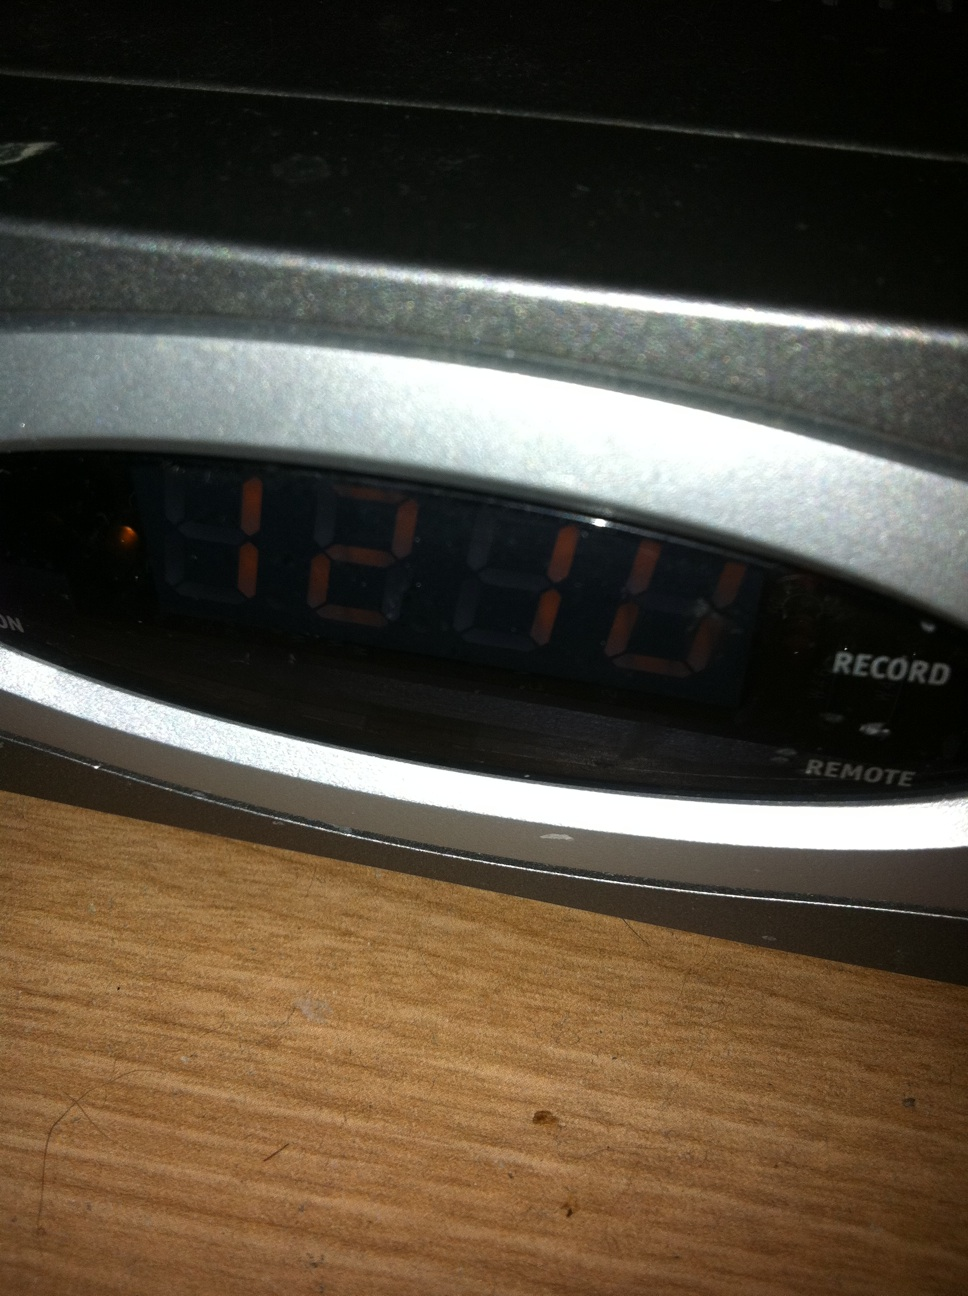Can you describe the overall look and condition of the set-top box? The set-top box appears to be in good condition with a sleek, metallic finish. There are no visible scratches or damage on the surface, which indicates it has been well-maintained. The display is clear, showing '12:10' with its illuminated digits. Additionally, there are labels such as 'RECORD' and 'REMOTE' visible on the interface, suggesting functionality for recording and remote control operations. Does the set-top box seem to have any advanced features? Based on the visible features, the set-top box does include functionalities such as recording, which could suggest it is a DVR (Digital Video Recorder). The presence of a 'REMOTE' label also implies it is remote-controllable. However, without seeing more of the device or having additional information, I cannot verify further advanced features like internet connectivity or smart functionalities. What kind of content could be recorded using this set-top box? Typically, a DVR-enabled set-top box would allow users to record television shows, movies, and other broadcast content. You could schedule recordings ahead of time, so you never miss your favorite programs. Given its DVR capability, it's likely that it can store multiple recordings on an internal or connected storage device, allowing playback at your convenience. Imagine if this set-top box could record events from a magical world. What kind of shows might it contain? If this set-top box could record events from a magical world, you might find shows like 'The Chronicles of Enchanted Realms,' where enchanted forests and mystical creatures come to life. There could be live broadcasts of wizard duels from the prestigious 'Academy of Spells,' daily updates on dragon flights across the sky, or even a reality show called 'Fairy Life,' documenting the daily adventures of fairies and their interactions with humans. Another popular show might be 'Mystic Tales,' featuring a storyteller who narrates ancient legends of heroism, love, and magic. Describe a realistic scenario on how someone might use this set-top box in their daily life. In a realistic scenario, a person might come home after a long day at work. They've set their favorite TV show to record earlier that morning using the set-top box. After making dinner and settling in, they sit down in front of the TV, use the remote to navigate the menu, and select the recorded show to play. As they watch, they may pause and rewind to catch details they missed, making their viewing experience more flexible and enjoyable. How might someone quickly check a recording during a busy day? During a busy day, someone might quickly check a recording by using the remote control to access the recorded content menu on the set-top box. They could do this while having a quick meal or while taking a short break from their tasks. By selecting the desired recording, they can briefly skim through the content to catch up on the highlights before returning to their busy schedule. 